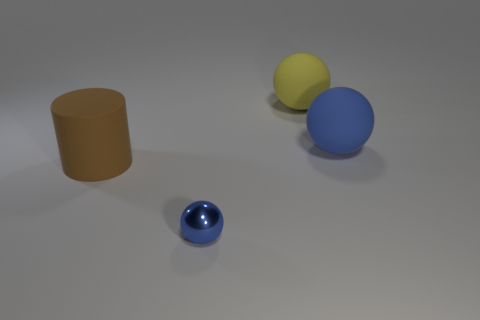How many balls are either big matte things or yellow matte things?
Ensure brevity in your answer.  2. Is there a blue rubber ball?
Keep it short and to the point. Yes. What number of other things are made of the same material as the small object?
Your answer should be compact. 0. There is a blue object that is the same size as the rubber cylinder; what material is it?
Your answer should be compact. Rubber. Do the thing in front of the big cylinder and the large yellow matte object have the same shape?
Make the answer very short. Yes. Is the color of the tiny metallic ball the same as the matte cylinder?
Offer a very short reply. No. How many objects are either large objects that are in front of the blue rubber thing or big blue rubber objects?
Provide a short and direct response. 2. The brown rubber thing that is the same size as the yellow matte object is what shape?
Give a very brief answer. Cylinder. There is a blue rubber ball on the right side of the metallic ball; is its size the same as the thing to the left of the blue shiny sphere?
Offer a terse response. Yes. The sphere that is made of the same material as the big yellow object is what color?
Your answer should be compact. Blue. 